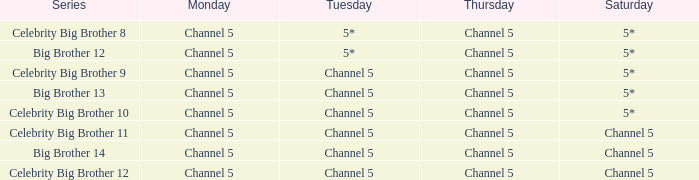Which Tuesday does big brother 12 air? 5*. 